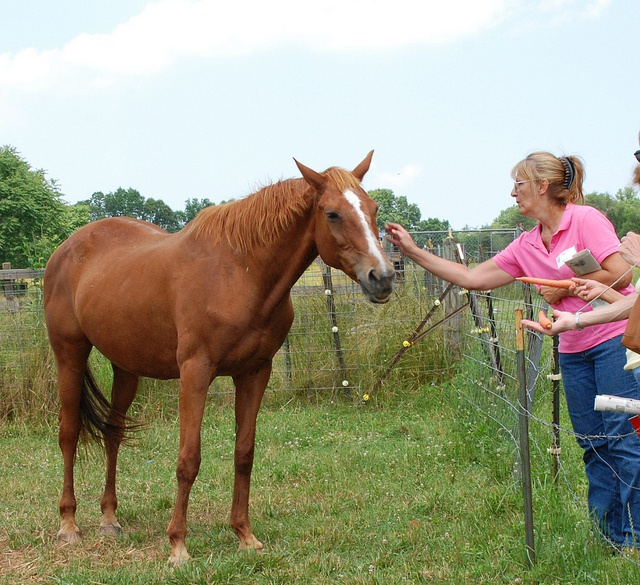Describe the objects in this image and their specific colors. I can see horse in white, maroon, brown, and black tones, people in white, navy, lightpink, brown, and blue tones, people in white, lightpink, brown, lightgray, and pink tones, carrot in white, salmon, tan, and brown tones, and carrot in white, tan, and salmon tones in this image. 